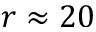Convert formula to latex. <formula><loc_0><loc_0><loc_500><loc_500>r \approx 2 0</formula> 